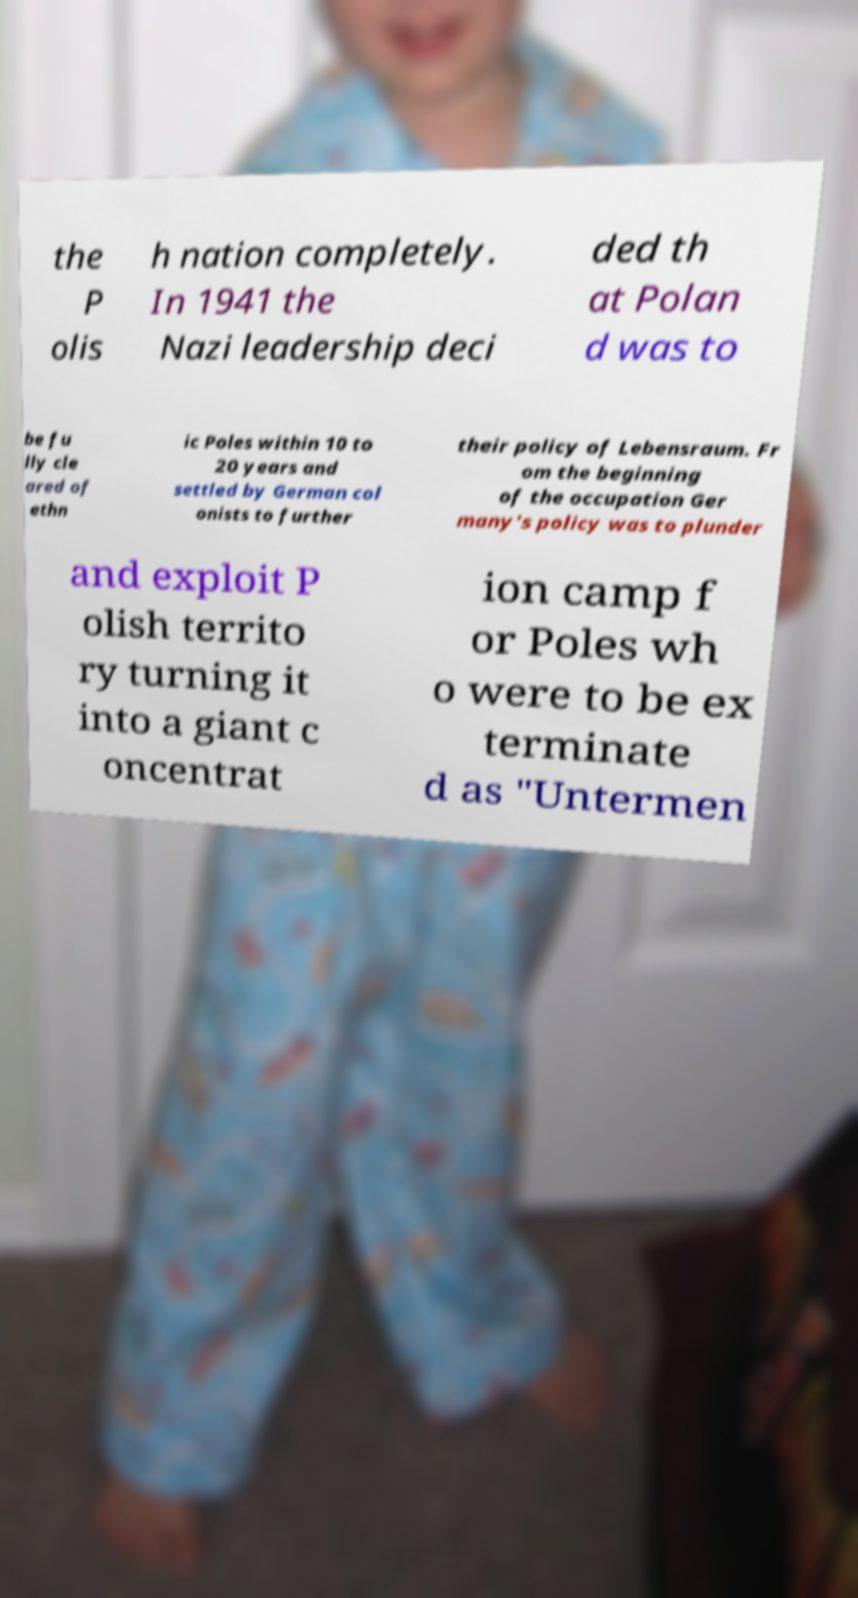What messages or text are displayed in this image? I need them in a readable, typed format. the P olis h nation completely. In 1941 the Nazi leadership deci ded th at Polan d was to be fu lly cle ared of ethn ic Poles within 10 to 20 years and settled by German col onists to further their policy of Lebensraum. Fr om the beginning of the occupation Ger many's policy was to plunder and exploit P olish territo ry turning it into a giant c oncentrat ion camp f or Poles wh o were to be ex terminate d as "Untermen 